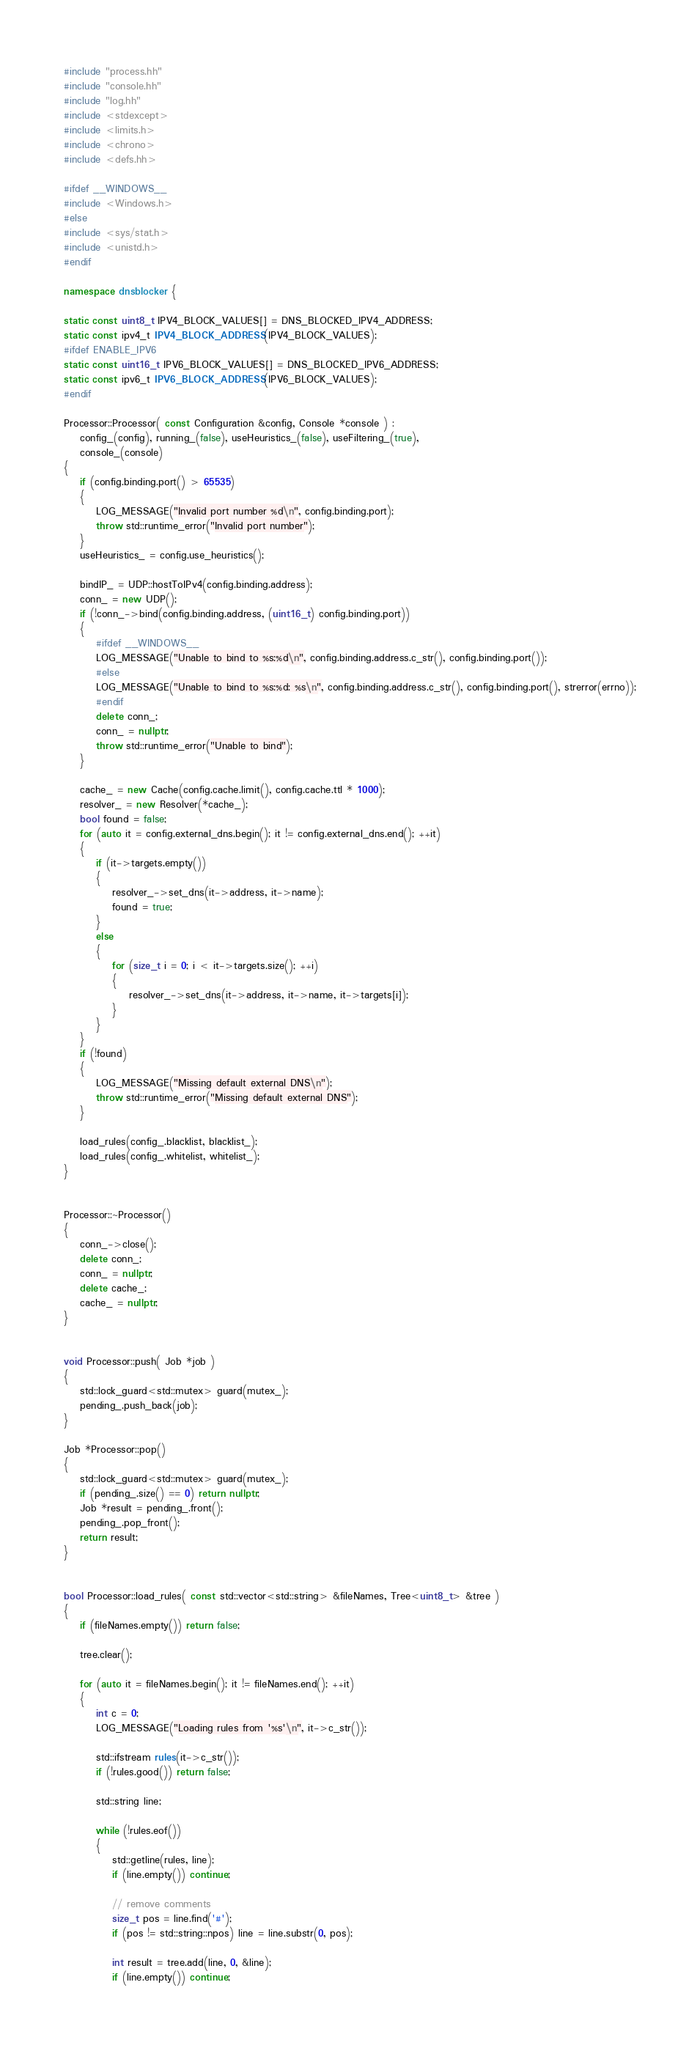<code> <loc_0><loc_0><loc_500><loc_500><_C++_>#include "process.hh"
#include "console.hh"
#include "log.hh"
#include <stdexcept>
#include <limits.h>
#include <chrono>
#include <defs.hh>

#ifdef __WINDOWS__
#include <Windows.h>
#else
#include <sys/stat.h>
#include <unistd.h>
#endif

namespace dnsblocker {

static const uint8_t IPV4_BLOCK_VALUES[] = DNS_BLOCKED_IPV4_ADDRESS;
static const ipv4_t IPV4_BLOCK_ADDRESS(IPV4_BLOCK_VALUES);
#ifdef ENABLE_IPV6
static const uint16_t IPV6_BLOCK_VALUES[] = DNS_BLOCKED_IPV6_ADDRESS;
static const ipv6_t IPV6_BLOCK_ADDRESS(IPV6_BLOCK_VALUES);
#endif

Processor::Processor( const Configuration &config, Console *console ) :
    config_(config), running_(false), useHeuristics_(false), useFiltering_(true),
    console_(console)
{
    if (config.binding.port() > 65535)
    {
        LOG_MESSAGE("Invalid port number %d\n", config.binding.port);
        throw std::runtime_error("Invalid port number");
    }
    useHeuristics_ = config.use_heuristics();

    bindIP_ = UDP::hostToIPv4(config.binding.address);
	conn_ = new UDP();
	if (!conn_->bind(config.binding.address, (uint16_t) config.binding.port))
    {
        #ifdef __WINDOWS__
		LOG_MESSAGE("Unable to bind to %s:%d\n", config.binding.address.c_str(), config.binding.port());
		#else
		LOG_MESSAGE("Unable to bind to %s:%d: %s\n", config.binding.address.c_str(), config.binding.port(), strerror(errno));
		#endif
        delete conn_;
		conn_ = nullptr;
        throw std::runtime_error("Unable to bind");
    }

    cache_ = new Cache(config.cache.limit(), config.cache.ttl * 1000);
    resolver_ = new Resolver(*cache_);
    bool found = false;
    for (auto it = config.external_dns.begin(); it != config.external_dns.end(); ++it)
    {
        if (it->targets.empty())
        {
            resolver_->set_dns(it->address, it->name);
            found = true;
        }
        else
        {
            for (size_t i = 0; i < it->targets.size(); ++i)
            {
                resolver_->set_dns(it->address, it->name, it->targets[i]);
            }
        }
    }
    if (!found)
    {
        LOG_MESSAGE("Missing default external DNS\n");
        throw std::runtime_error("Missing default external DNS");
    }

    load_rules(config_.blacklist, blacklist_);
    load_rules(config_.whitelist, whitelist_);
}


Processor::~Processor()
{
	conn_->close();
	delete conn_;
	conn_ = nullptr;
    delete cache_;
	cache_ = nullptr;
}


void Processor::push( Job *job )
{
    std::lock_guard<std::mutex> guard(mutex_);
    pending_.push_back(job);
}

Job *Processor::pop()
{
    std::lock_guard<std::mutex> guard(mutex_);
    if (pending_.size() == 0) return nullptr;
    Job *result = pending_.front();
    pending_.pop_front();
    return result;
}


bool Processor::load_rules( const std::vector<std::string> &fileNames, Tree<uint8_t> &tree )
{
    if (fileNames.empty()) return false;

    tree.clear();

    for (auto it = fileNames.begin(); it != fileNames.end(); ++it)
    {
        int c = 0;
        LOG_MESSAGE("Loading rules from '%s'\n", it->c_str());

        std::ifstream rules(it->c_str());
        if (!rules.good()) return false;

        std::string line;

        while (!rules.eof())
        {
            std::getline(rules, line);
            if (line.empty()) continue;

            // remove comments
            size_t pos = line.find('#');
            if (pos != std::string::npos) line = line.substr(0, pos);

            int result = tree.add(line, 0, &line);
            if (line.empty()) continue;
</code> 